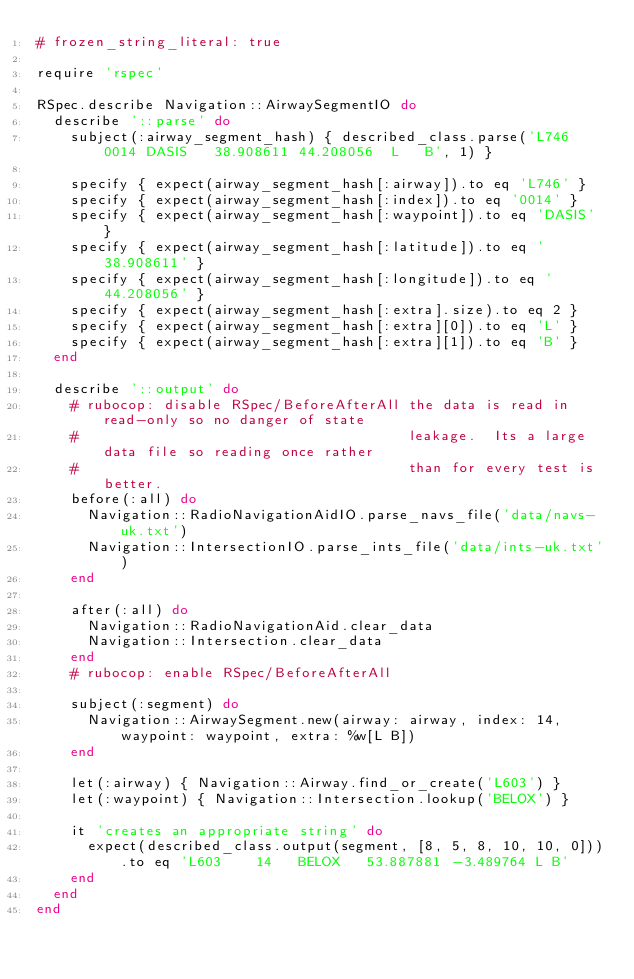Convert code to text. <code><loc_0><loc_0><loc_500><loc_500><_Ruby_># frozen_string_literal: true

require 'rspec'

RSpec.describe Navigation::AirwaySegmentIO do
  describe '::parse' do
    subject(:airway_segment_hash) { described_class.parse('L746    0014 DASIS   38.908611 44.208056  L   B', 1) }

    specify { expect(airway_segment_hash[:airway]).to eq 'L746' }
    specify { expect(airway_segment_hash[:index]).to eq '0014' }
    specify { expect(airway_segment_hash[:waypoint]).to eq 'DASIS' }
    specify { expect(airway_segment_hash[:latitude]).to eq '38.908611' }
    specify { expect(airway_segment_hash[:longitude]).to eq '44.208056' }
    specify { expect(airway_segment_hash[:extra].size).to eq 2 }
    specify { expect(airway_segment_hash[:extra][0]).to eq 'L' }
    specify { expect(airway_segment_hash[:extra][1]).to eq 'B' }
  end

  describe '::output' do
    # rubocop: disable RSpec/BeforeAfterAll the data is read in read-only so no danger of state
    #                                       leakage.  Its a large data file so reading once rather
    #                                       than for every test is better.
    before(:all) do
      Navigation::RadioNavigationAidIO.parse_navs_file('data/navs-uk.txt')
      Navigation::IntersectionIO.parse_ints_file('data/ints-uk.txt')
    end

    after(:all) do
      Navigation::RadioNavigationAid.clear_data
      Navigation::Intersection.clear_data
    end
    # rubocop: enable RSpec/BeforeAfterAll

    subject(:segment) do
      Navigation::AirwaySegment.new(airway: airway, index: 14, waypoint: waypoint, extra: %w[L B])
    end

    let(:airway) { Navigation::Airway.find_or_create('L603') }
    let(:waypoint) { Navigation::Intersection.lookup('BELOX') }

    it 'creates an appropriate string' do
      expect(described_class.output(segment, [8, 5, 8, 10, 10, 0])).to eq 'L603    14   BELOX   53.887881 -3.489764 L B'
    end
  end
end</code> 